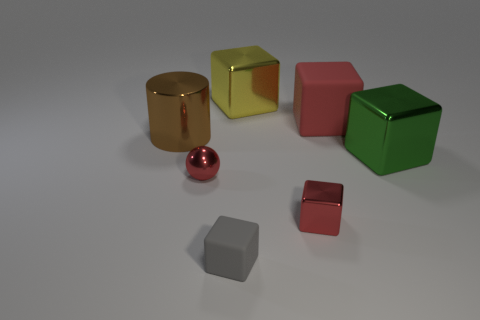Are there any small gray objects to the right of the red cube in front of the big cylinder left of the small gray rubber object? After observing the image, I can confirm that there are no small gray objects positioned to the right of the red cube. All visible objects are well-defined and distinctly colored, with no small gray objects situated in the described location. 